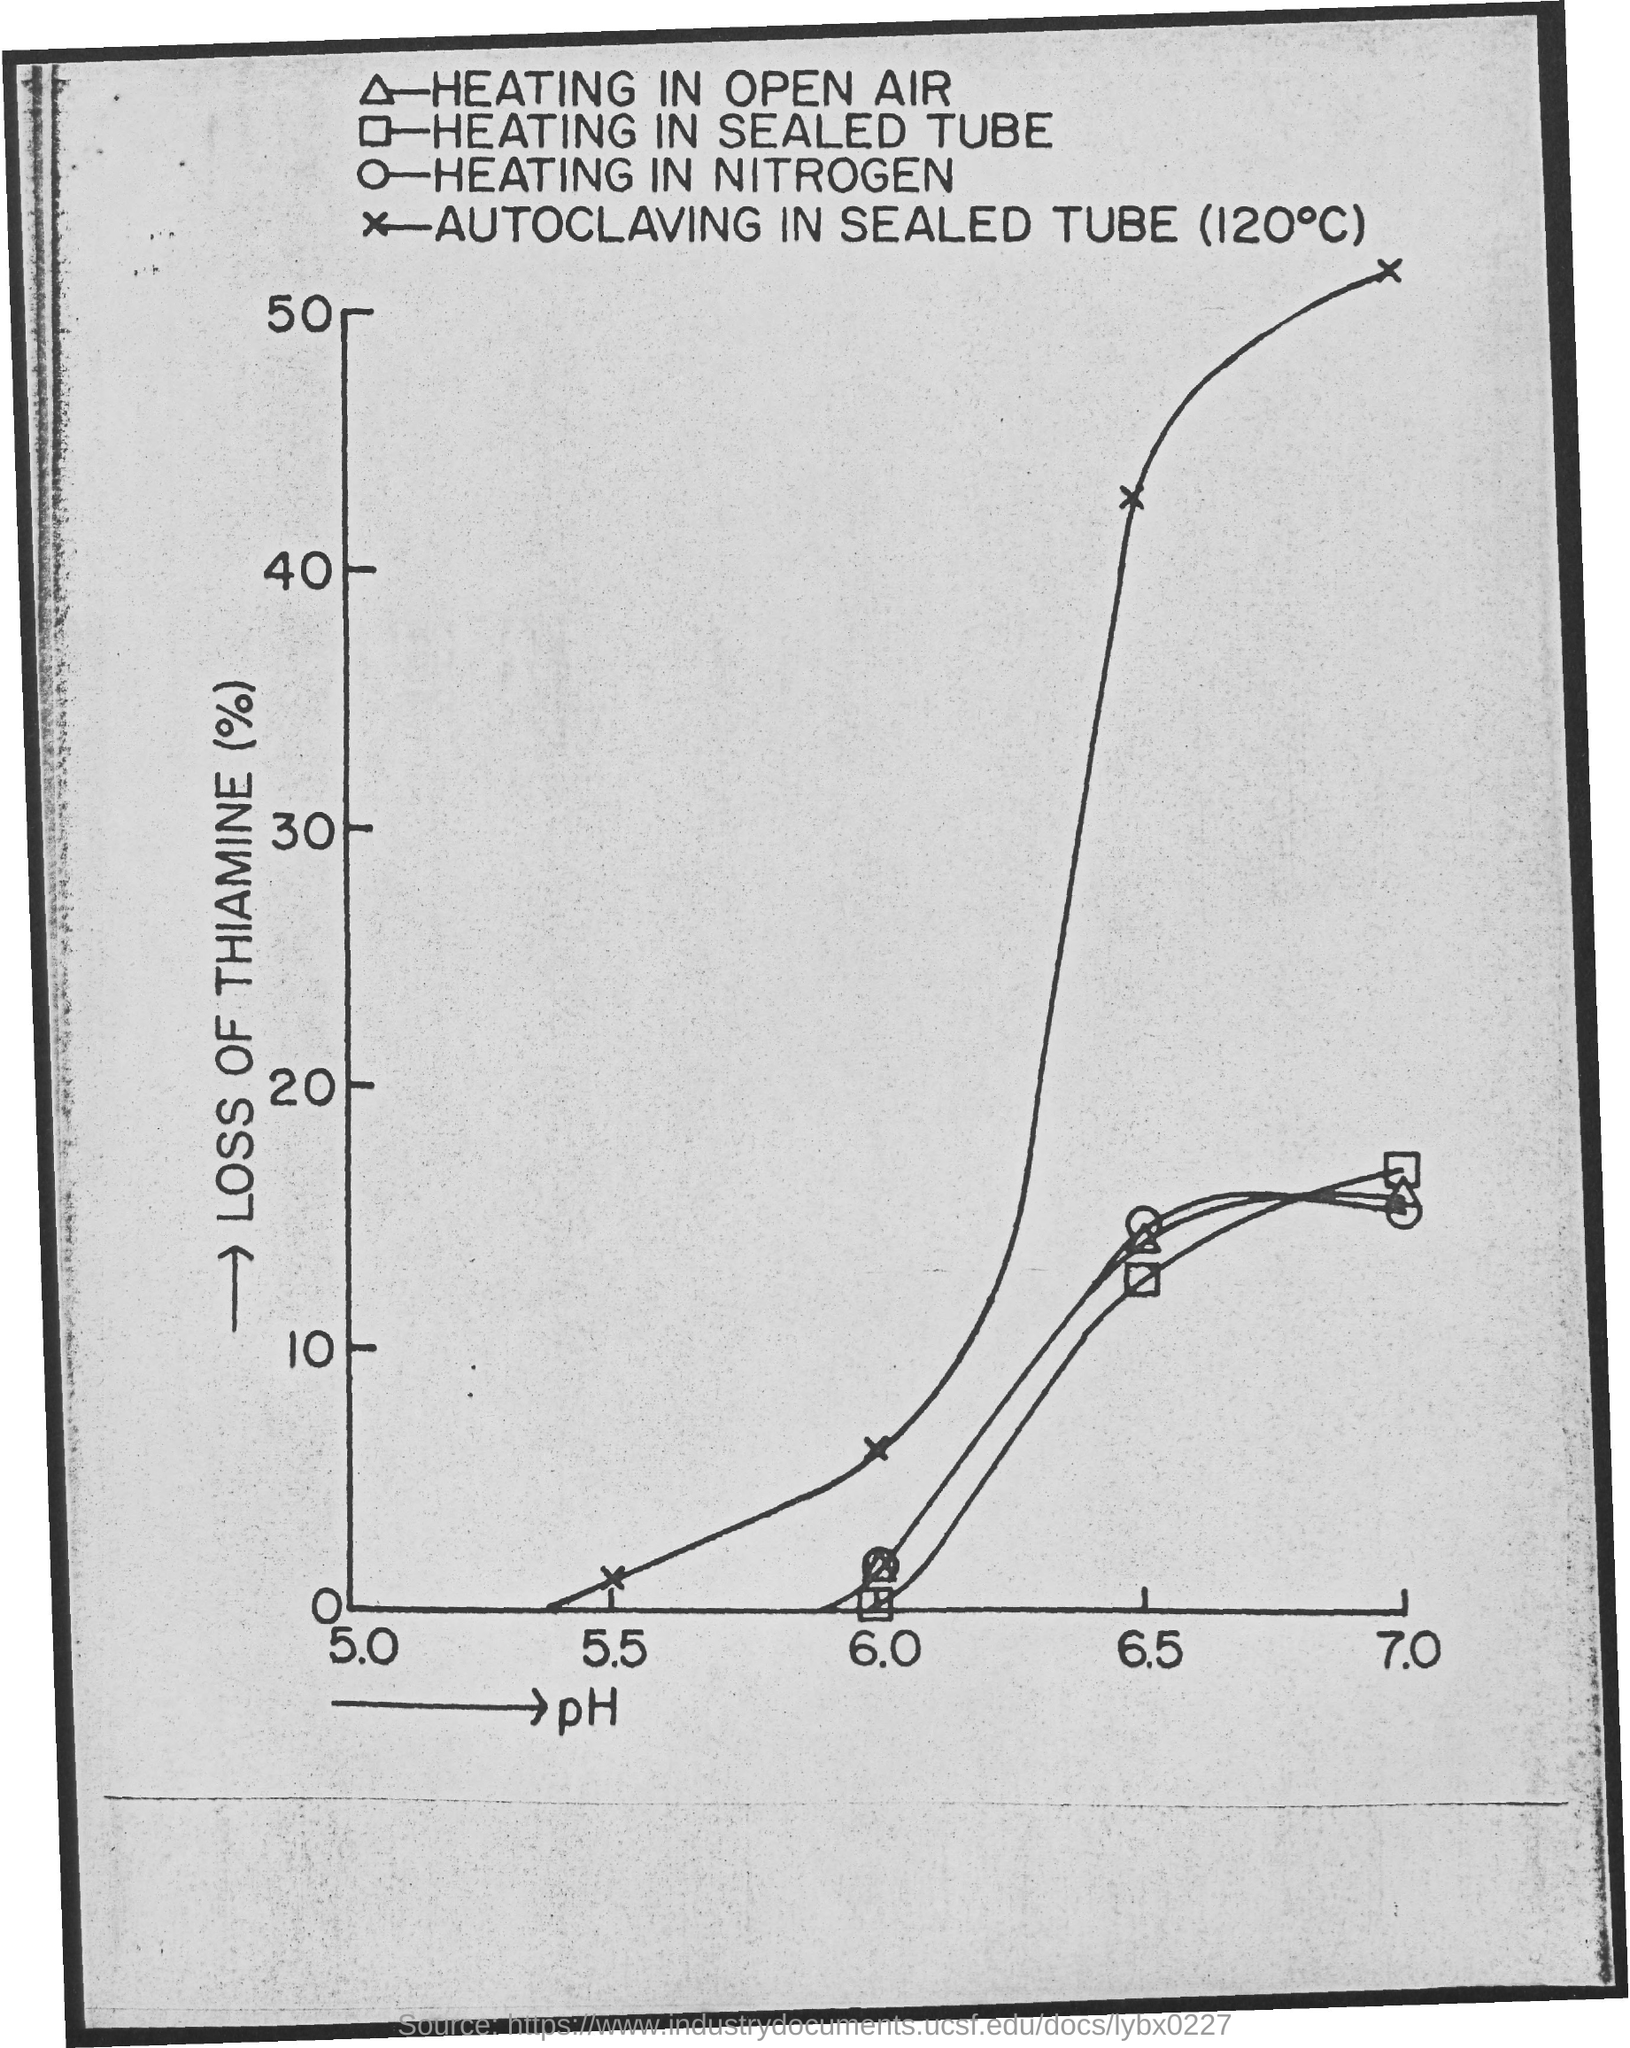What is mentioned on x-axis of the graph?
Provide a short and direct response. Ph. What is on the Y-axis of the graph?
Your response must be concise. Loss of thiamine (%). What is the minimum pH value mentioned on x-axis of graph?
Your answer should be very brief. 5.0. What is the maximum pH value mentioned on x-axis of graph?
Provide a short and direct response. 7.0. What is the minimum "LOSS OF THIAMINE(%)" value mentioned on y-axis of graph?
Provide a succinct answer. 0. What is the maximum "LOSS OF THIAMINE(%)" value mentioned on y-axis of graph?
Provide a succinct answer. 50. "HEATING IN SEALED TUBE" with pH 6.0, what is the "LOSS OF THIAMINE(%)?
Provide a short and direct response. 0. What does "o" represent?
Your response must be concise. HEATING IN NITROGEN. 